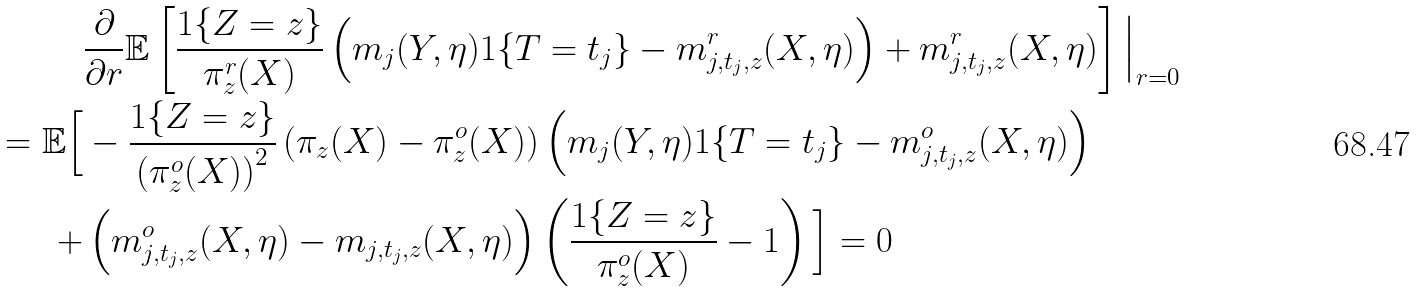Convert formula to latex. <formula><loc_0><loc_0><loc_500><loc_500>& \frac { \partial } { \partial r } \mathbb { E } \left [ \frac { 1 \{ Z = z \} } { \pi ^ { r } _ { z } ( X ) } \left ( m _ { j } ( Y , \eta ) 1 \{ T = t _ { j } \} - m ^ { r } _ { j , t _ { j } , z } ( X , \eta ) \right ) + m ^ { r } _ { j , t _ { j } , z } ( X , \eta ) \right ] \Big | _ { r = 0 } \\ = \mathbb { E } \Big [ & - \frac { 1 \{ Z = z \} } { \left ( \pi ^ { o } _ { z } ( X ) \right ) ^ { 2 } } \left ( \pi _ { z } ( X ) - \pi _ { z } ^ { o } ( X ) \right ) \left ( m _ { j } ( Y , \eta ) 1 \{ T = t _ { j } \} - m ^ { o } _ { j , t _ { j } , z } ( X , \eta ) \right ) \\ + & \left ( m ^ { o } _ { j , t _ { j } , z } ( X , \eta ) - m _ { j , t _ { j } , z } ( X , \eta ) \right ) \left ( \frac { 1 \{ Z = z \} } { \pi ^ { o } _ { z } ( X ) } - 1 \right ) \Big ] = 0</formula> 